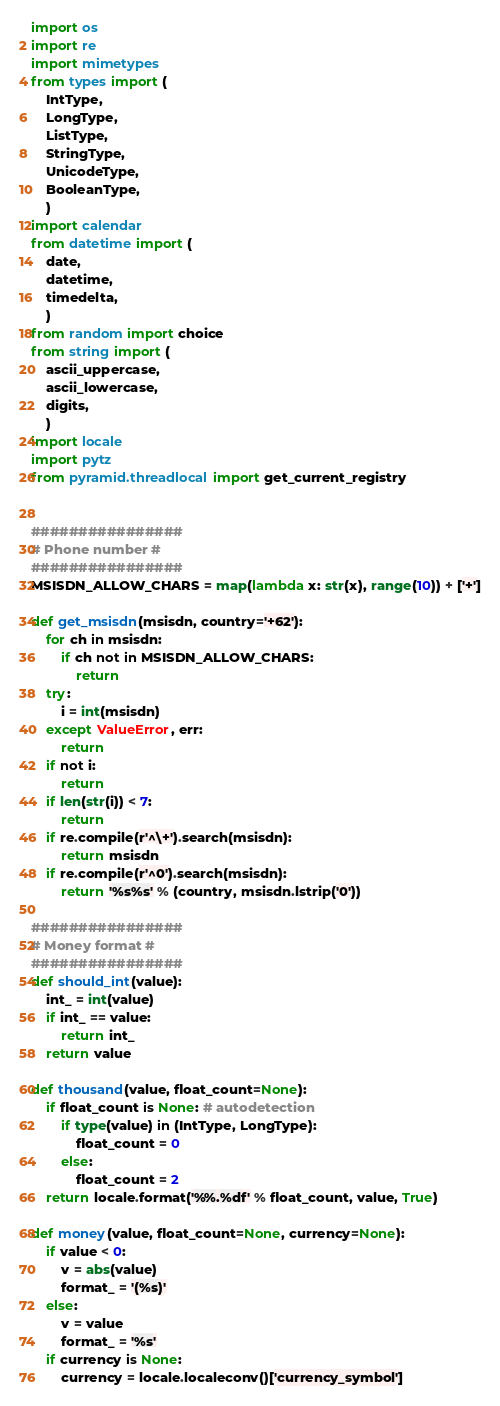<code> <loc_0><loc_0><loc_500><loc_500><_Python_>import os
import re
import mimetypes
from types import (
    IntType,
    LongType,
    ListType,
    StringType,
    UnicodeType,
    BooleanType,
    )
import calendar    
from datetime import (
    date,
    datetime,
    timedelta,
    )
from random import choice
from string import (
    ascii_uppercase,
    ascii_lowercase,
    digits,
    )
import locale
import pytz
from pyramid.threadlocal import get_current_registry


################
# Phone number #
################
MSISDN_ALLOW_CHARS = map(lambda x: str(x), range(10)) + ['+']

def get_msisdn(msisdn, country='+62'):
    for ch in msisdn:
        if ch not in MSISDN_ALLOW_CHARS:
            return
    try:
        i = int(msisdn)
    except ValueError, err:
        return
    if not i:
        return
    if len(str(i)) < 7:
        return
    if re.compile(r'^\+').search(msisdn):
        return msisdn
    if re.compile(r'^0').search(msisdn):
        return '%s%s' % (country, msisdn.lstrip('0'))

################
# Money format #
################
def should_int(value):
    int_ = int(value)
    if int_ == value:
        return int_
    return value

def thousand(value, float_count=None):
    if float_count is None: # autodetection
        if type(value) in (IntType, LongType):
            float_count = 0
        else:
            float_count = 2
    return locale.format('%%.%df' % float_count, value, True)

def money(value, float_count=None, currency=None):
    if value < 0:
        v = abs(value)
        format_ = '(%s)'
    else:
        v = value
        format_ = '%s'
    if currency is None:
        currency = locale.localeconv()['currency_symbol']</code> 